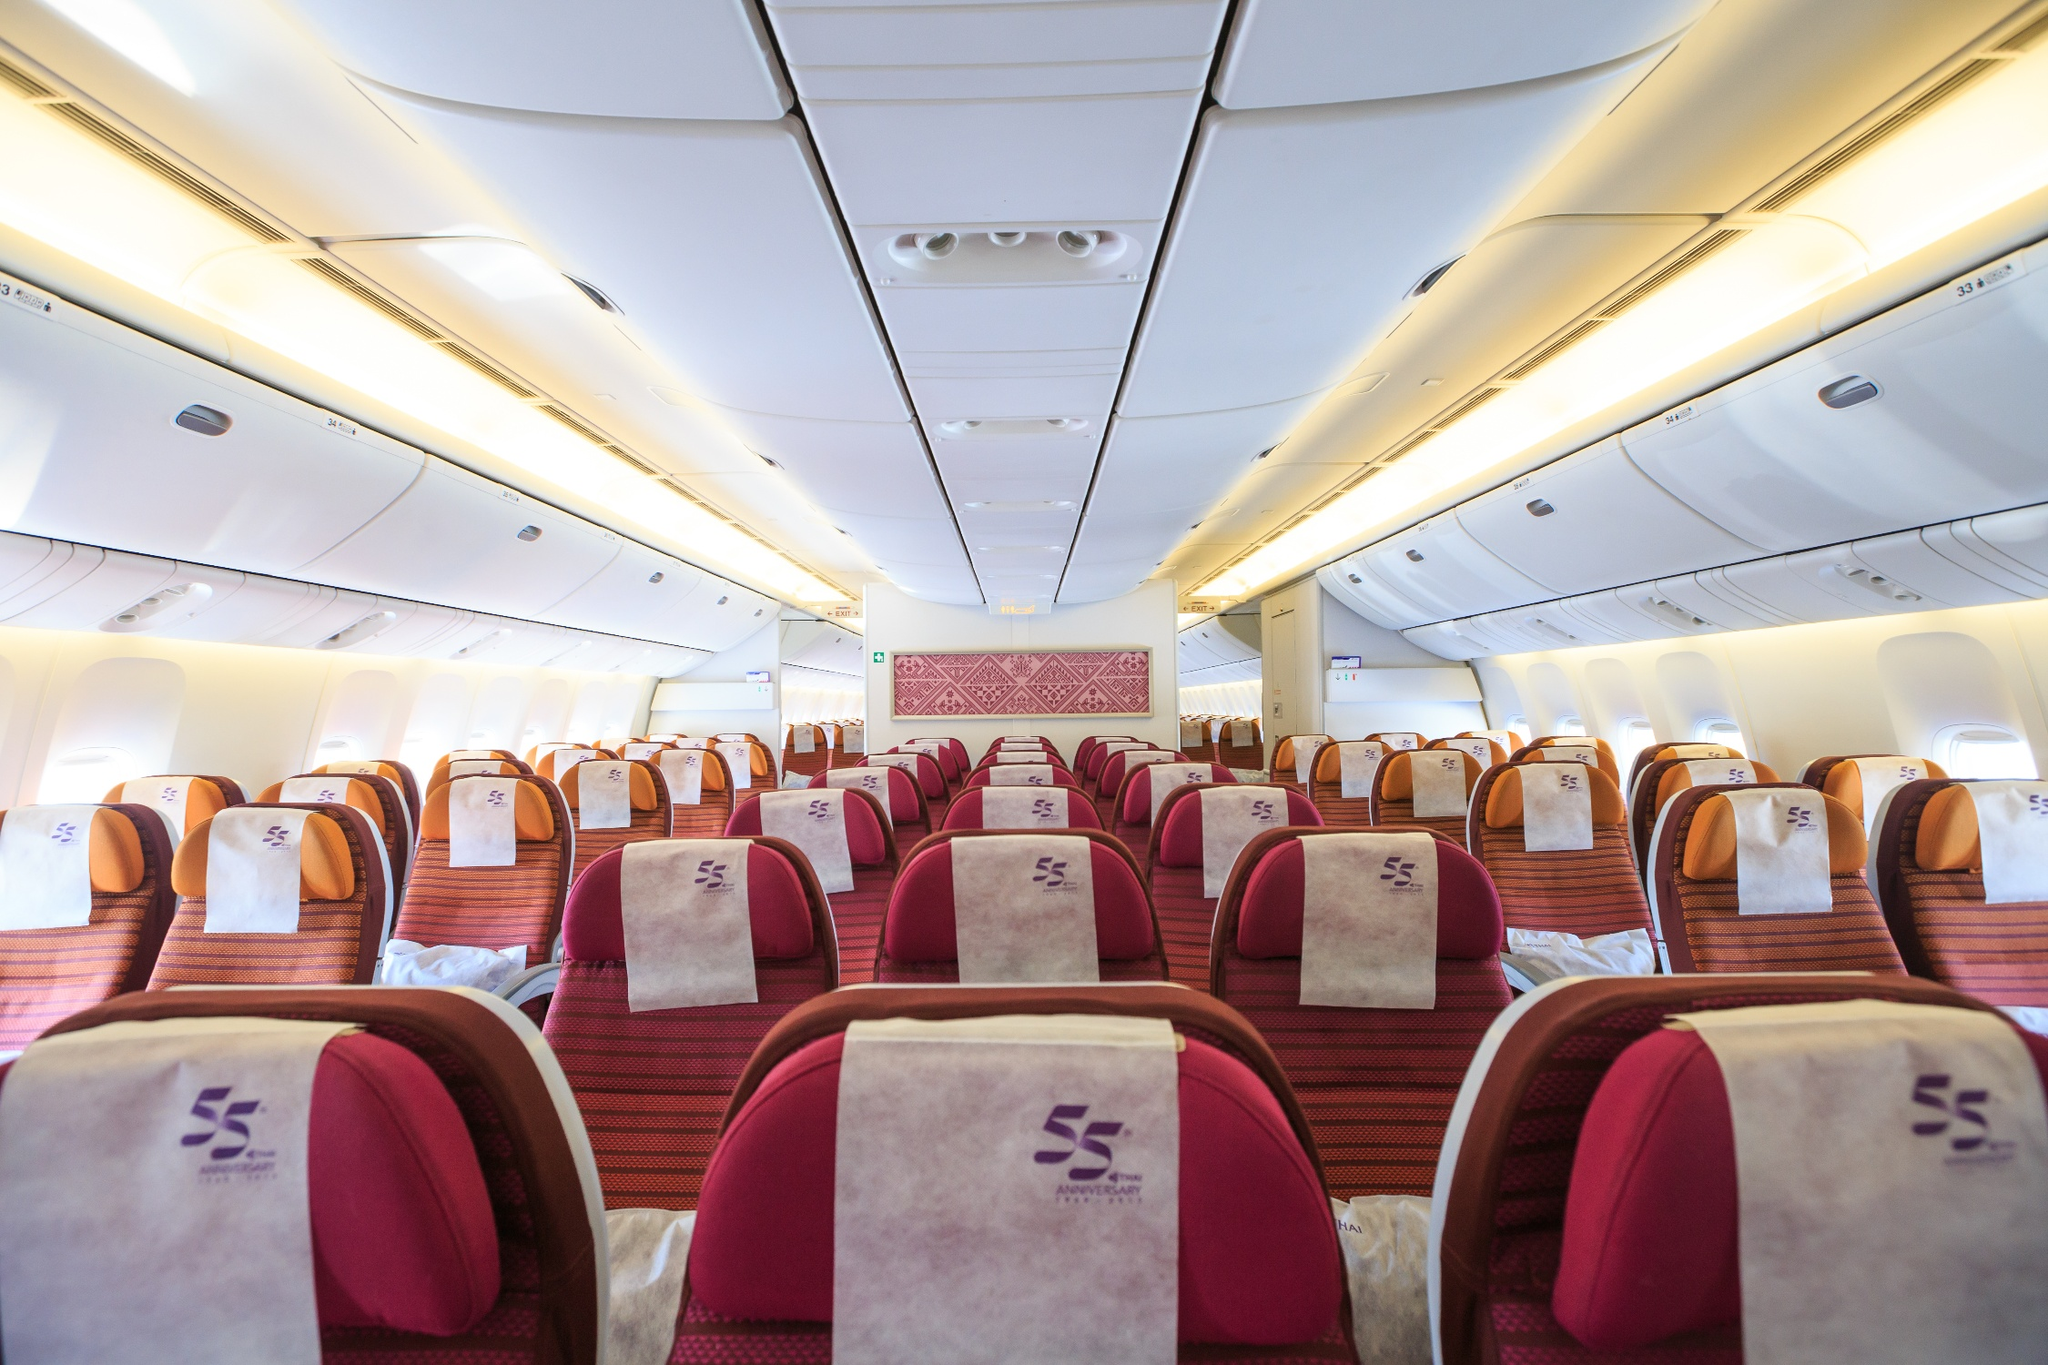What does the design and color scheme of the airplane's interior suggest about the airline? The choice of deep red for the seats, combined with the beige overhead compartments and white headrests, suggests that the airline aims to evoke a sense of luxury and comfort. The presence of the stylized 'S' logo in purple on each headrest may indicate the airline's branding, which seems to prioritize elegance and a high-quality experience. The intricate pink pattern on the partition could be reflective of cultural significance or could be an attempt to create a distinctive and memorable cabin atmosphere. 